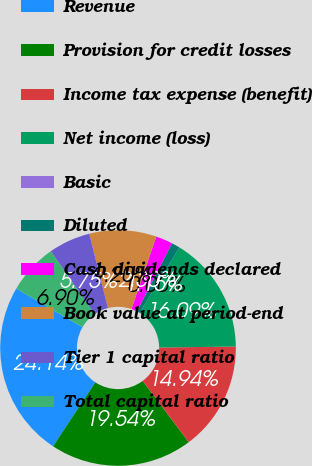Convert chart to OTSL. <chart><loc_0><loc_0><loc_500><loc_500><pie_chart><fcel>Revenue<fcel>Provision for credit losses<fcel>Income tax expense (benefit)<fcel>Net income (loss)<fcel>Basic<fcel>Diluted<fcel>Cash dividends declared<fcel>Book value at period-end<fcel>Tier 1 capital ratio<fcel>Total capital ratio<nl><fcel>24.14%<fcel>19.54%<fcel>14.94%<fcel>16.09%<fcel>0.0%<fcel>1.15%<fcel>2.3%<fcel>9.2%<fcel>5.75%<fcel>6.9%<nl></chart> 